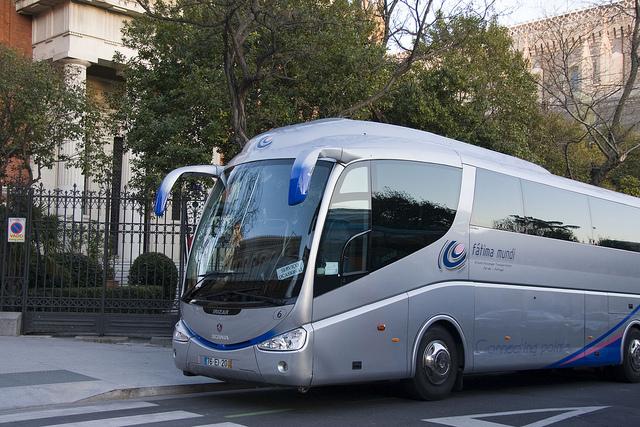What type of fence is in the background?
Keep it brief. Iron. Is the bus moving?
Be succinct. No. Is there a dog in this picture?
Give a very brief answer. No. What kind of bus is this?
Answer briefly. Tour. 